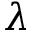Convert formula to latex. <formula><loc_0><loc_0><loc_500><loc_500>\lambda</formula> 